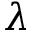Convert formula to latex. <formula><loc_0><loc_0><loc_500><loc_500>\lambda</formula> 